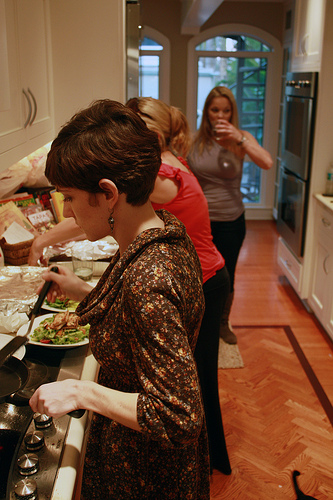Please provide the bounding box coordinate of the region this sentence describes: part of a white ceiling beam. [0.52, 0.0, 0.6, 0.07]. This box includes part of a white beam, possibly on the ceiling, giving structure to the room. 